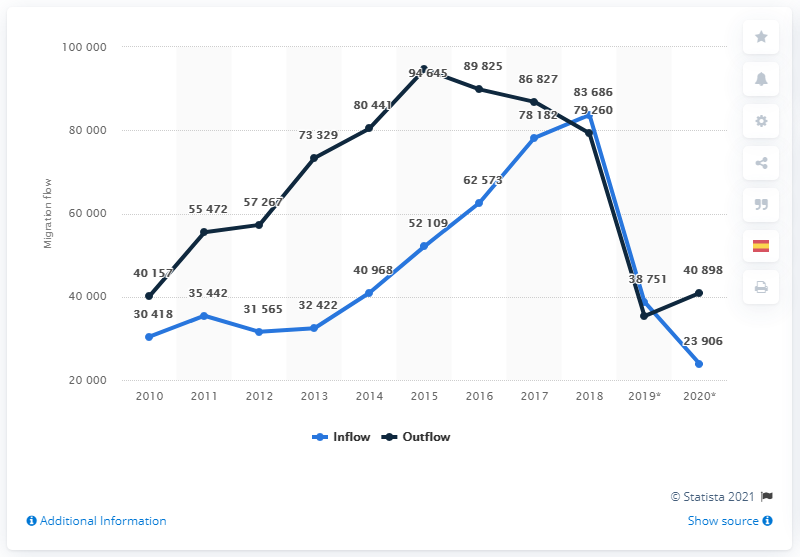Draw attention to some important aspects in this diagram. In 2019, there was a significant decrease in the number of individuals migrating into a particular region. This decline in inflow migration was the steepest among all the years observed. The number of Spaniards returning to Spain began to fall in 2016. In 2020, a total of 40,968 Spaniards returned to Spain. The sum of the lowest points of the navy blue and blue lines is 62657. In 2015, a significant number of Spaniards emigrated from Spain. 